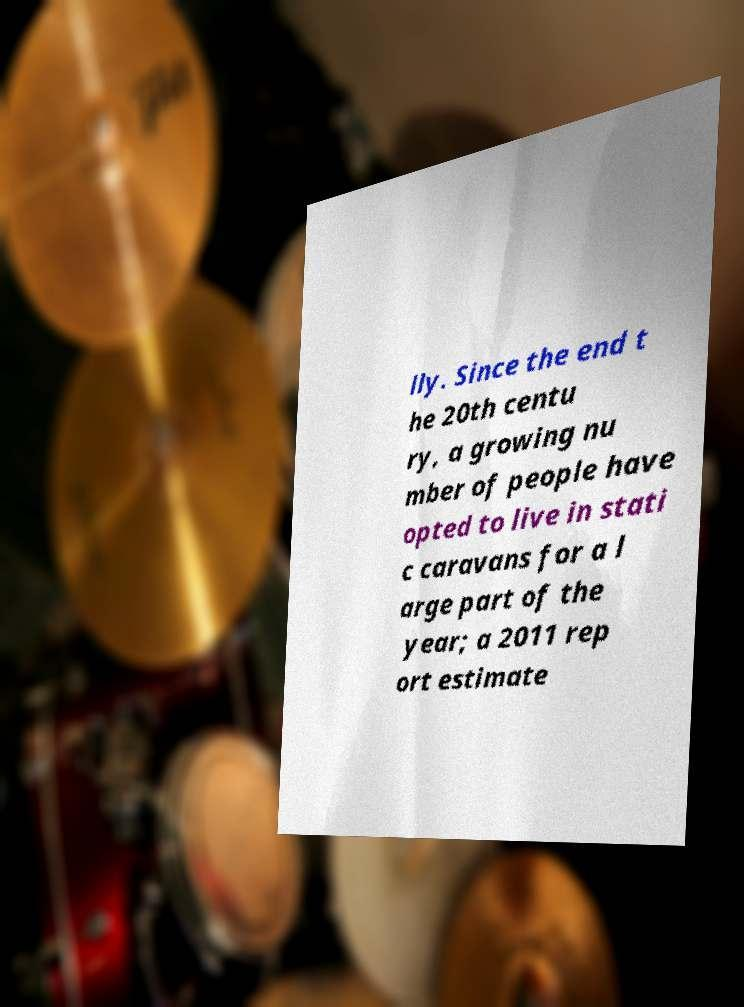For documentation purposes, I need the text within this image transcribed. Could you provide that? lly. Since the end t he 20th centu ry, a growing nu mber of people have opted to live in stati c caravans for a l arge part of the year; a 2011 rep ort estimate 